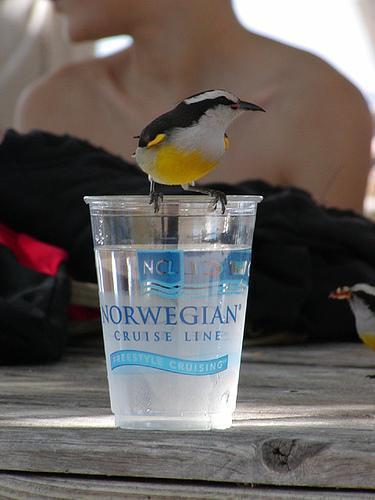What type of vehicle is this cup from?
Make your selection and explain in format: 'Answer: answer
Rationale: rationale.'
Options: Ship, bus, plane, train. Answer: ship.
Rationale: The cup says "norwegian cruise line". 